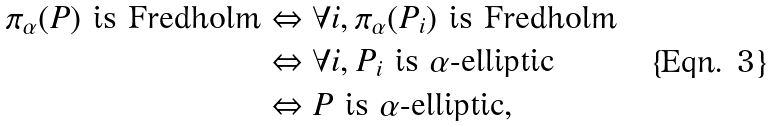<formula> <loc_0><loc_0><loc_500><loc_500>\pi _ { \alpha } ( P ) \text { is Fredholm} & \Leftrightarrow \forall i , \pi _ { \alpha } ( P _ { i } ) \text { is Fredholm} \\ & \Leftrightarrow \forall i , P _ { i } \text { is                   $\alpha$-elliptic} \\ & \Leftrightarrow P \text { is                   $\alpha$-elliptic} ,</formula> 